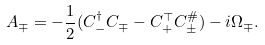<formula> <loc_0><loc_0><loc_500><loc_500>A _ { \mp } = - \frac { 1 } { 2 } ( C _ { - } ^ { \dag } C _ { \mp } - C _ { + } ^ { \top } C _ { \pm } ^ { \# } ) - i \Omega _ { \mp } .</formula> 